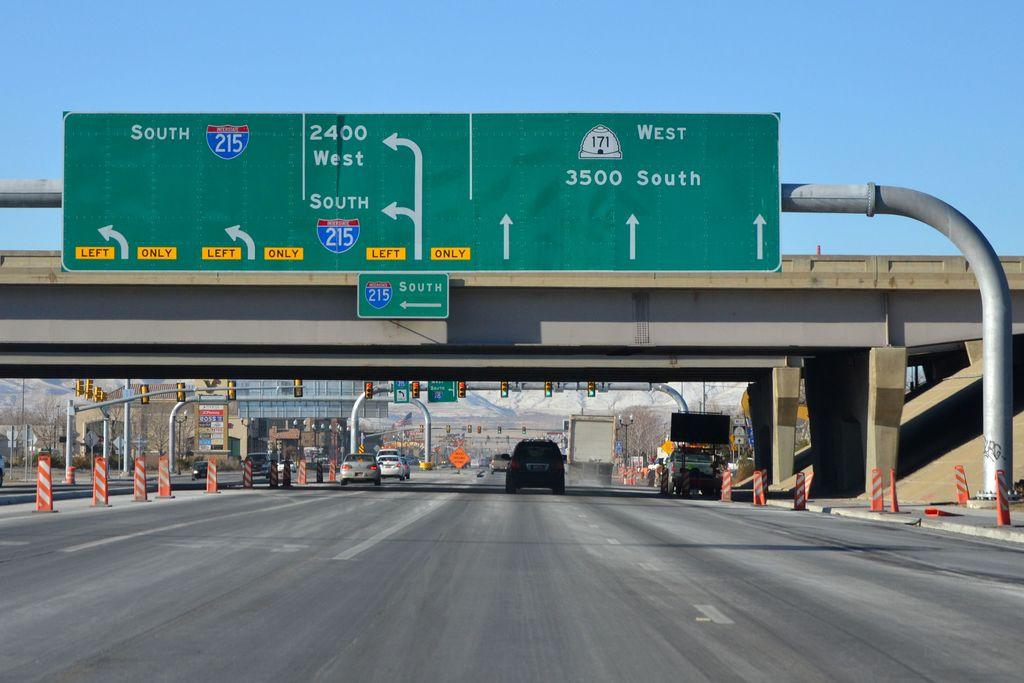What lanes should i be in if i want to go on 215 south?
Your answer should be very brief. Left. What direction would you go if you took 3500 south?
Your response must be concise. West. 